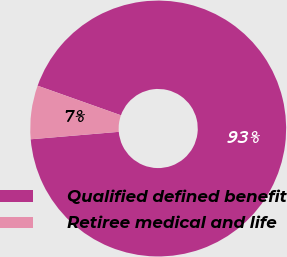Convert chart to OTSL. <chart><loc_0><loc_0><loc_500><loc_500><pie_chart><fcel>Qualified defined benefit<fcel>Retiree medical and life<nl><fcel>93.23%<fcel>6.77%<nl></chart> 